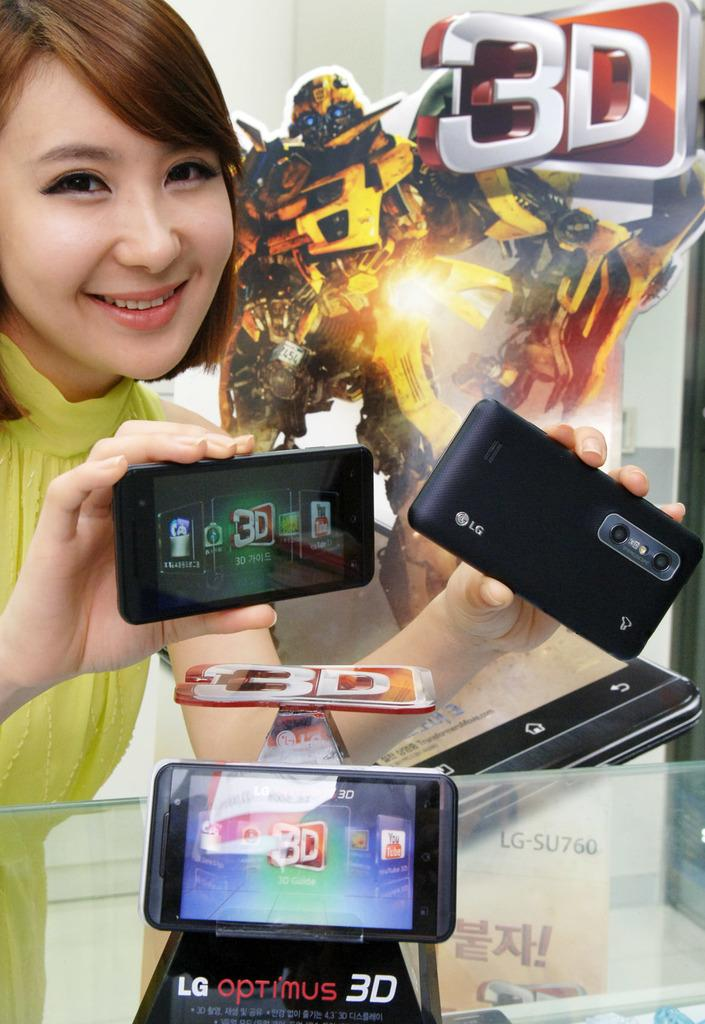Provide a one-sentence caption for the provided image. An Asian woman with short red-brown hair and a green shirt holds two LG Smartphones in her hands over a glass table with another smart phone set on it. 